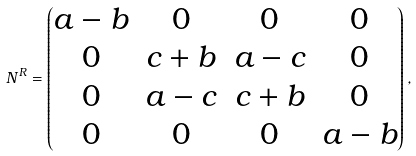<formula> <loc_0><loc_0><loc_500><loc_500>N ^ { R } = \begin{pmatrix} a - b & 0 & 0 & 0 \\ 0 & c + b & a - c & 0 \\ 0 & a - c & c + b & 0 \\ 0 & 0 & 0 & a - b \end{pmatrix} ,</formula> 